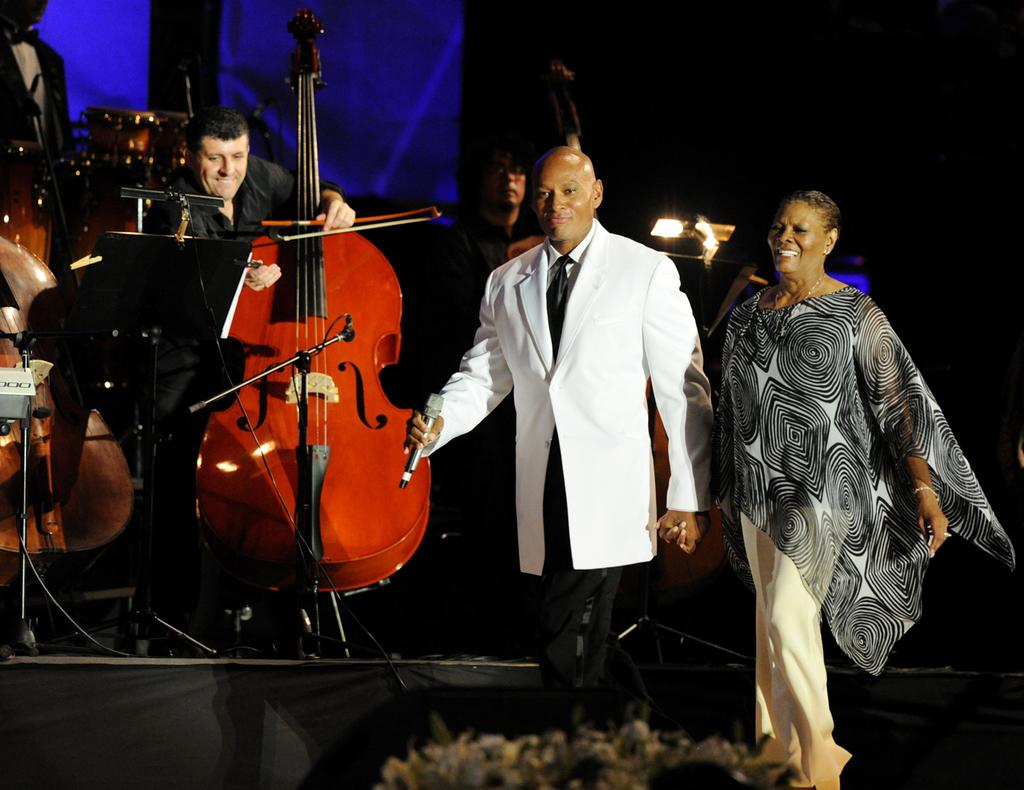What are the people in the image doing? The people in the image are playing musical instruments. Are there any other activities happening in the image? Yes, two people are dancing. What time of day is it in the picture, given that the people are dancing in the morning? There is no information about the time of day in the image, and the people dancing are not necessarily dancing in the morning. 